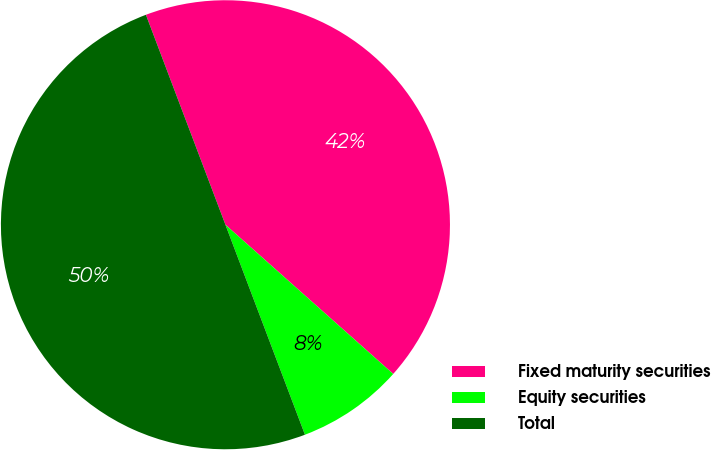Convert chart. <chart><loc_0><loc_0><loc_500><loc_500><pie_chart><fcel>Fixed maturity securities<fcel>Equity securities<fcel>Total<nl><fcel>42.33%<fcel>7.67%<fcel>50.0%<nl></chart> 